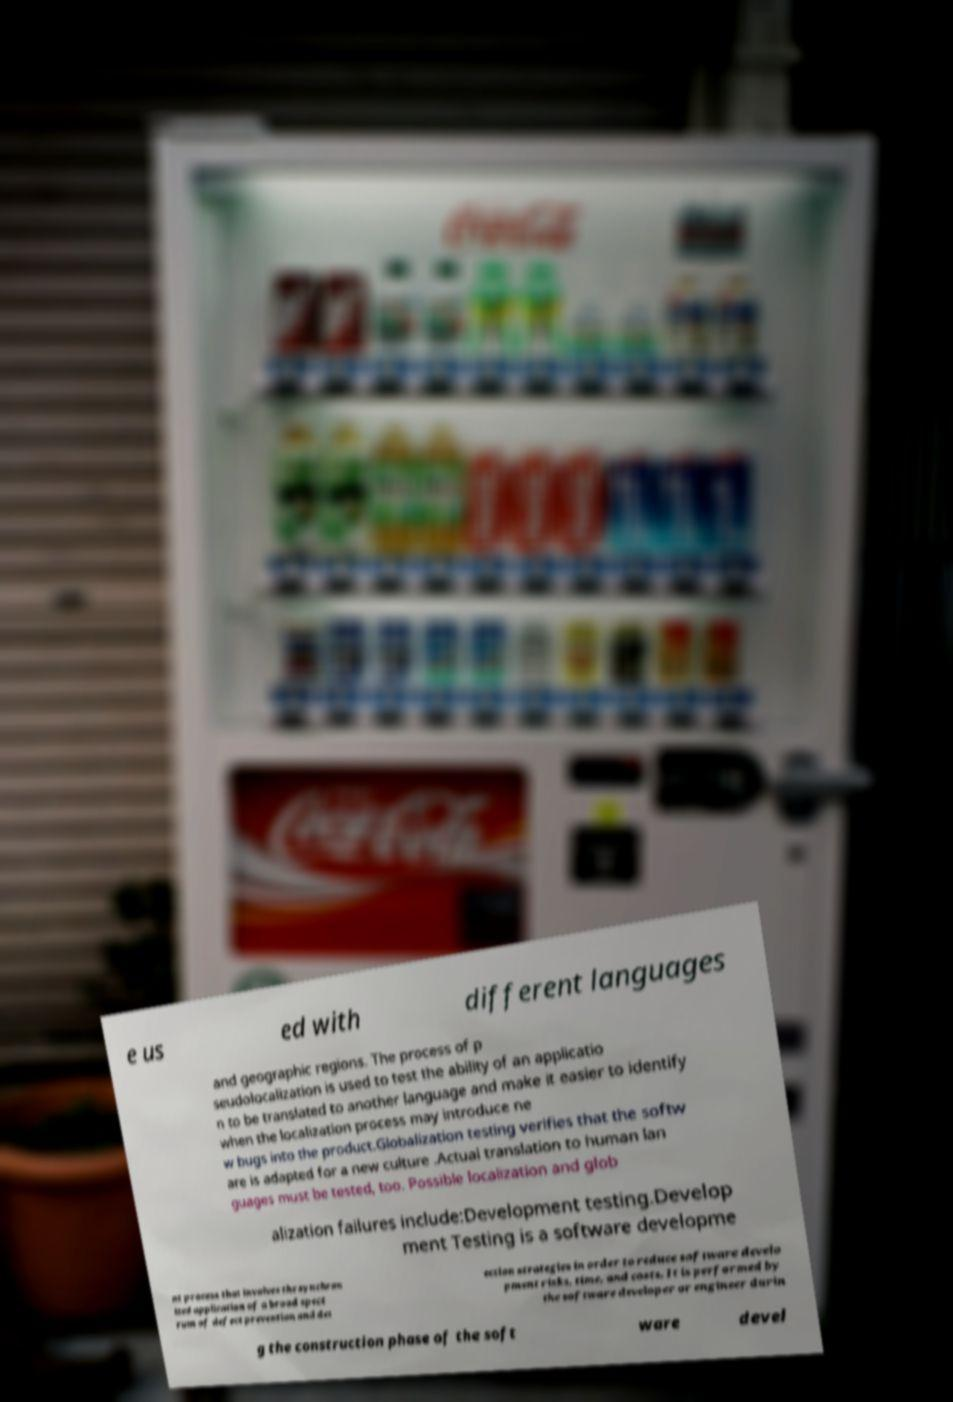I need the written content from this picture converted into text. Can you do that? e us ed with different languages and geographic regions. The process of p seudolocalization is used to test the ability of an applicatio n to be translated to another language and make it easier to identify when the localization process may introduce ne w bugs into the product.Globalization testing verifies that the softw are is adapted for a new culture .Actual translation to human lan guages must be tested, too. Possible localization and glob alization failures include:Development testing.Develop ment Testing is a software developme nt process that involves the synchron ized application of a broad spect rum of defect prevention and det ection strategies in order to reduce software develo pment risks, time, and costs. It is performed by the software developer or engineer durin g the construction phase of the soft ware devel 